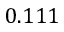Convert formula to latex. <formula><loc_0><loc_0><loc_500><loc_500>0 . 1 1 1</formula> 